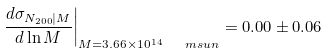Convert formula to latex. <formula><loc_0><loc_0><loc_500><loc_500>\left . \frac { d \sigma _ { N _ { 2 0 0 } | M } } { d \ln M } \right | _ { M = 3 . 6 6 \times 1 0 ^ { 1 4 } \ \ m s u n } = 0 . 0 0 \pm 0 . 0 6</formula> 